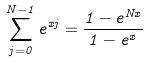Convert formula to latex. <formula><loc_0><loc_0><loc_500><loc_500>\sum _ { j = 0 } ^ { N - 1 } e ^ { x j } = \frac { 1 - e ^ { N x } } { 1 - e ^ { x } }</formula> 